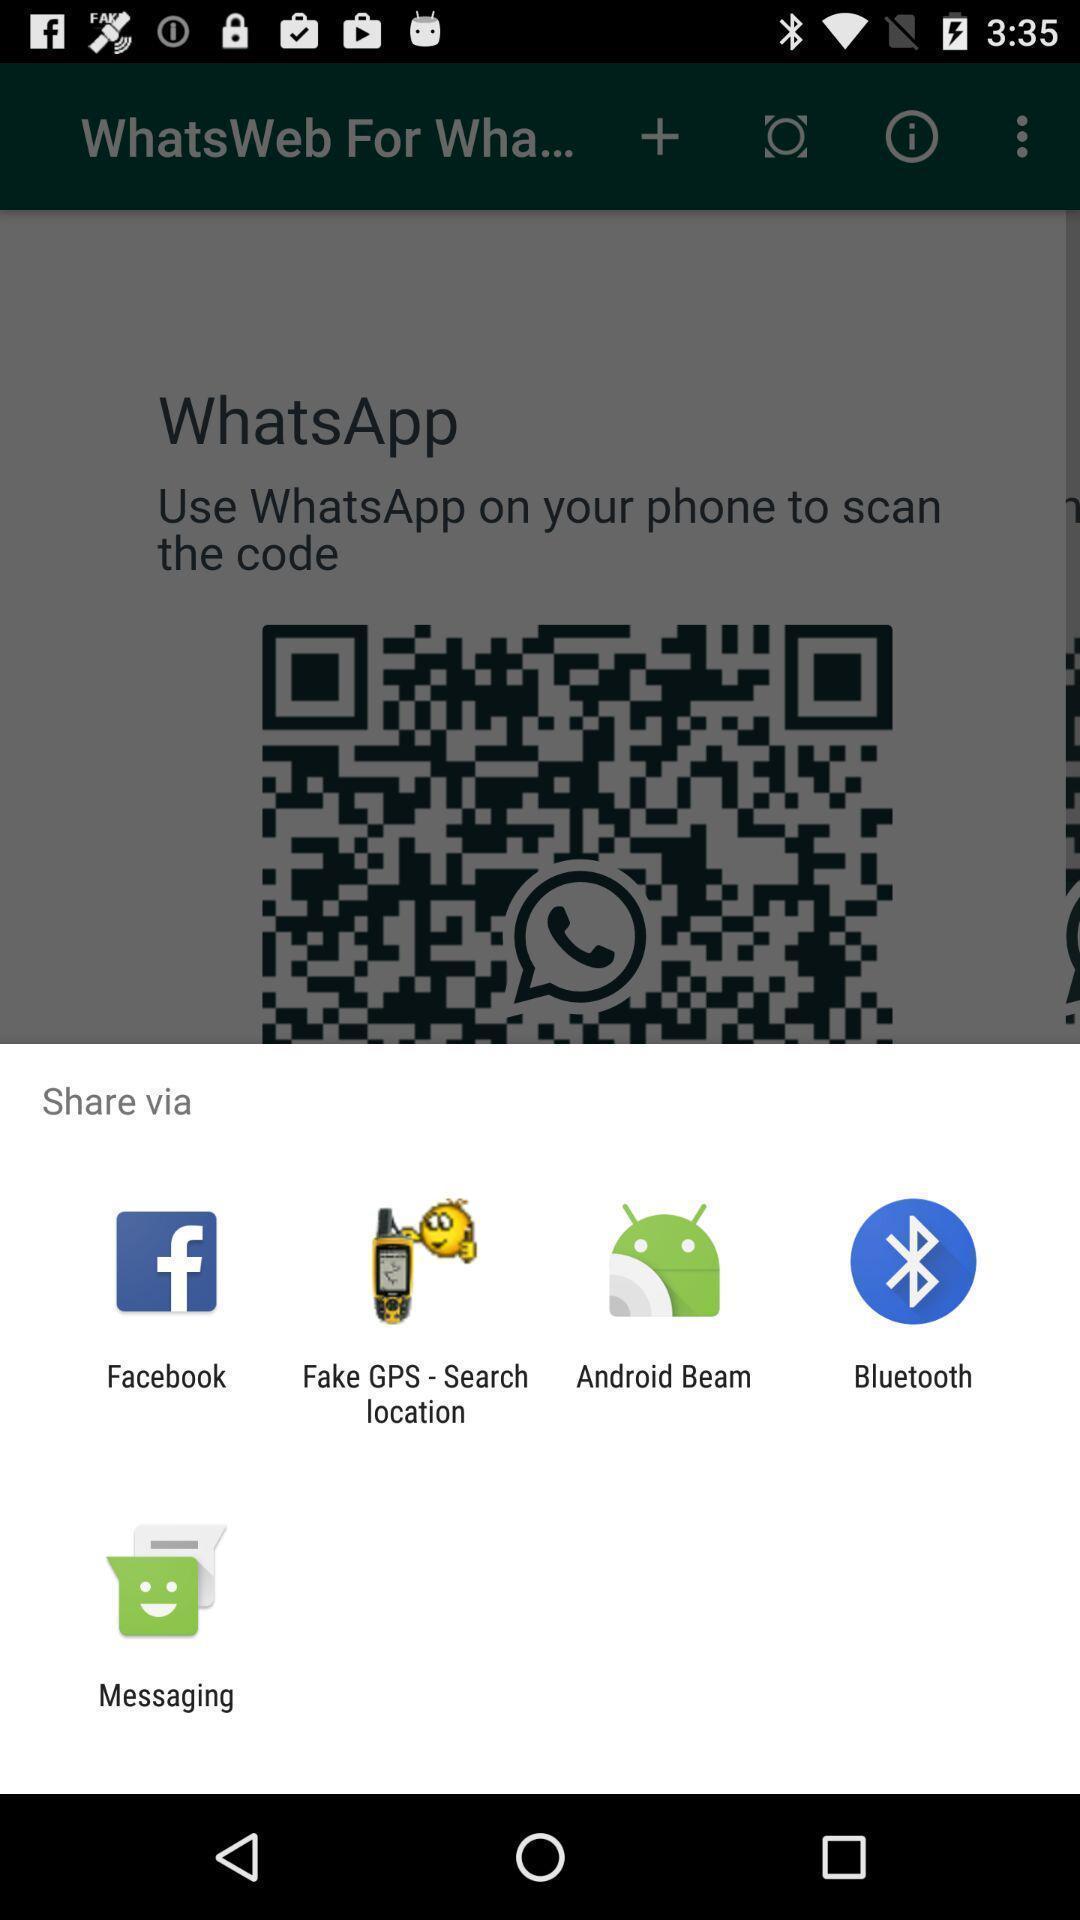Explain what's happening in this screen capture. Pop-up showing various share options of a social app. 